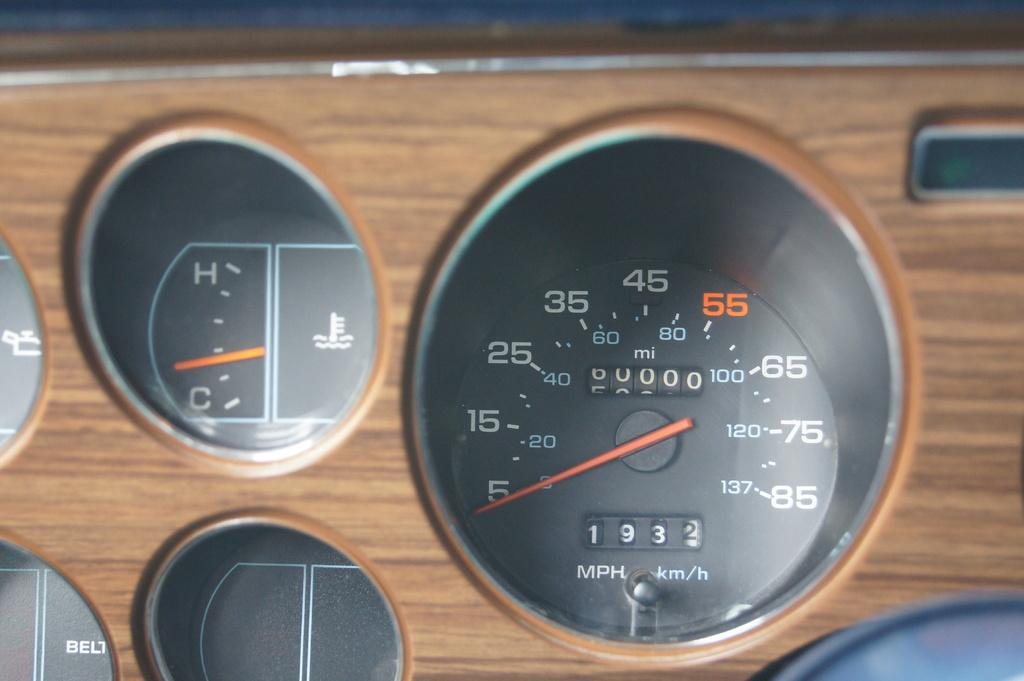What is the main object in the image? The main object in the image is a speedometer. What is the speedometer attached to? The speedometer is on a wooden object. Who is the father of the person wearing the vest in the image? There is no person wearing a vest or any reference to a father in the image; it only features a speedometer on a wooden object. 